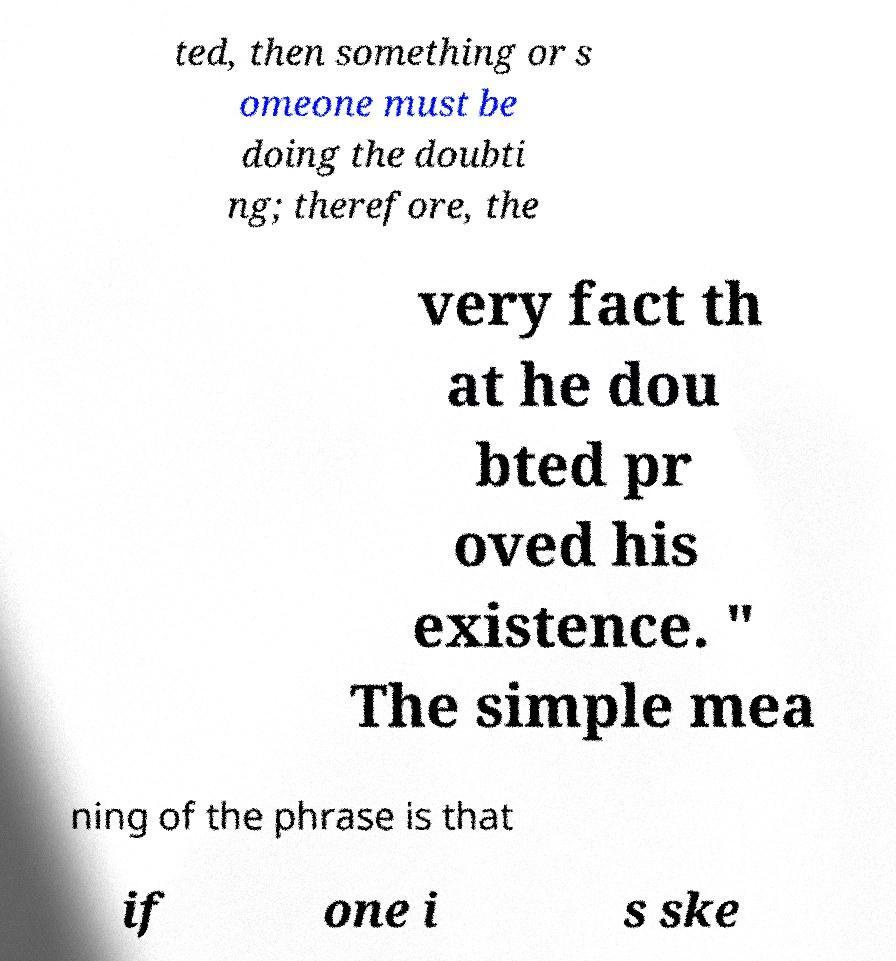What messages or text are displayed in this image? I need them in a readable, typed format. ted, then something or s omeone must be doing the doubti ng; therefore, the very fact th at he dou bted pr oved his existence. " The simple mea ning of the phrase is that if one i s ske 